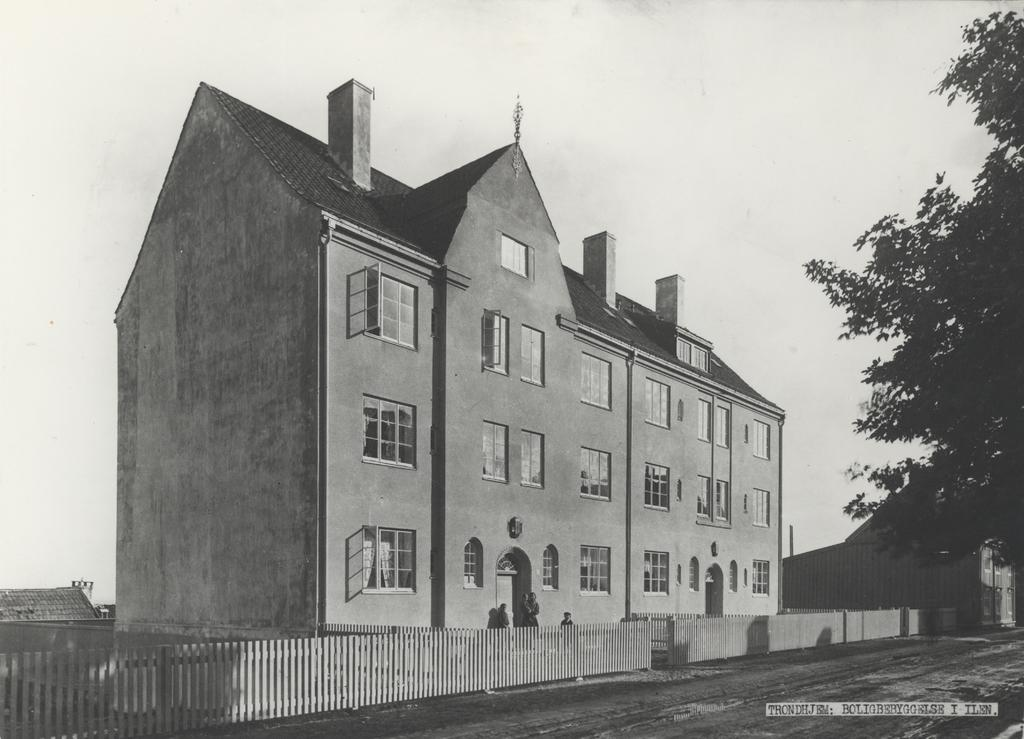What type of structure is visible in the image? There is a building in the image. What is located in front of the building? There is a fence wall in front of the building. Where is the tree situated in the image? The tree is in the right corner of the image. How many women are sitting on the edge of the tin in the image? There is no tin or women present in the image. 